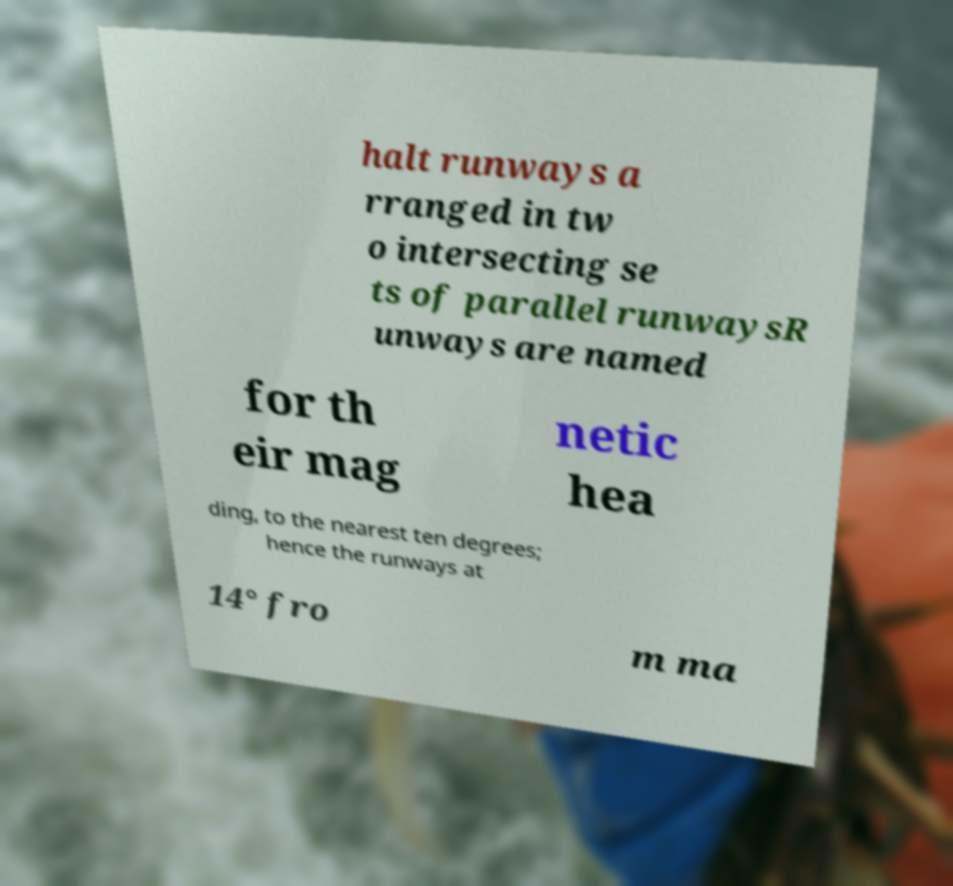Please read and relay the text visible in this image. What does it say? halt runways a rranged in tw o intersecting se ts of parallel runwaysR unways are named for th eir mag netic hea ding, to the nearest ten degrees; hence the runways at 14° fro m ma 